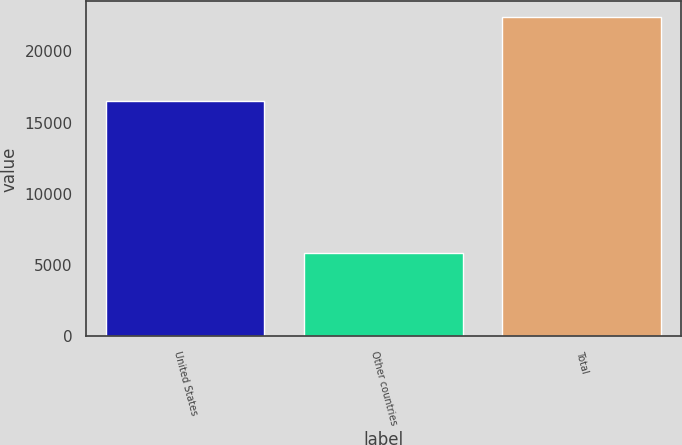Convert chart. <chart><loc_0><loc_0><loc_500><loc_500><bar_chart><fcel>United States<fcel>Other countries<fcel>Total<nl><fcel>16527.1<fcel>5859.7<fcel>22386.8<nl></chart> 